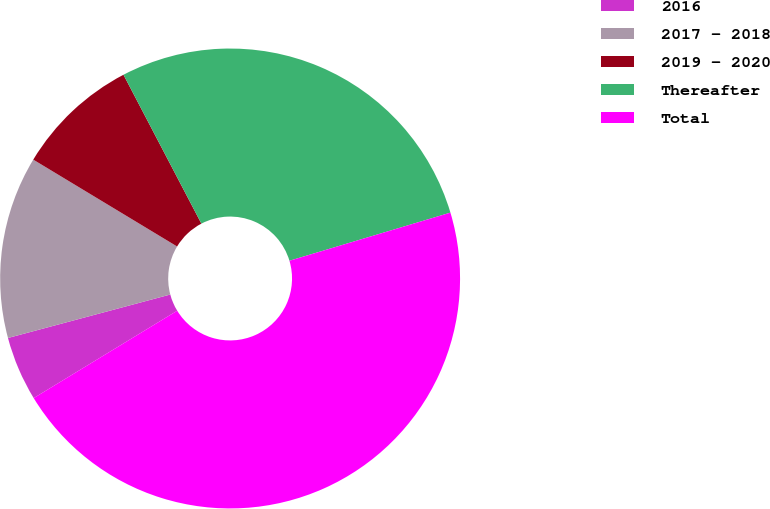Convert chart to OTSL. <chart><loc_0><loc_0><loc_500><loc_500><pie_chart><fcel>2016<fcel>2017 - 2018<fcel>2019 - 2020<fcel>Thereafter<fcel>Total<nl><fcel>4.54%<fcel>12.81%<fcel>8.68%<fcel>28.05%<fcel>45.92%<nl></chart> 